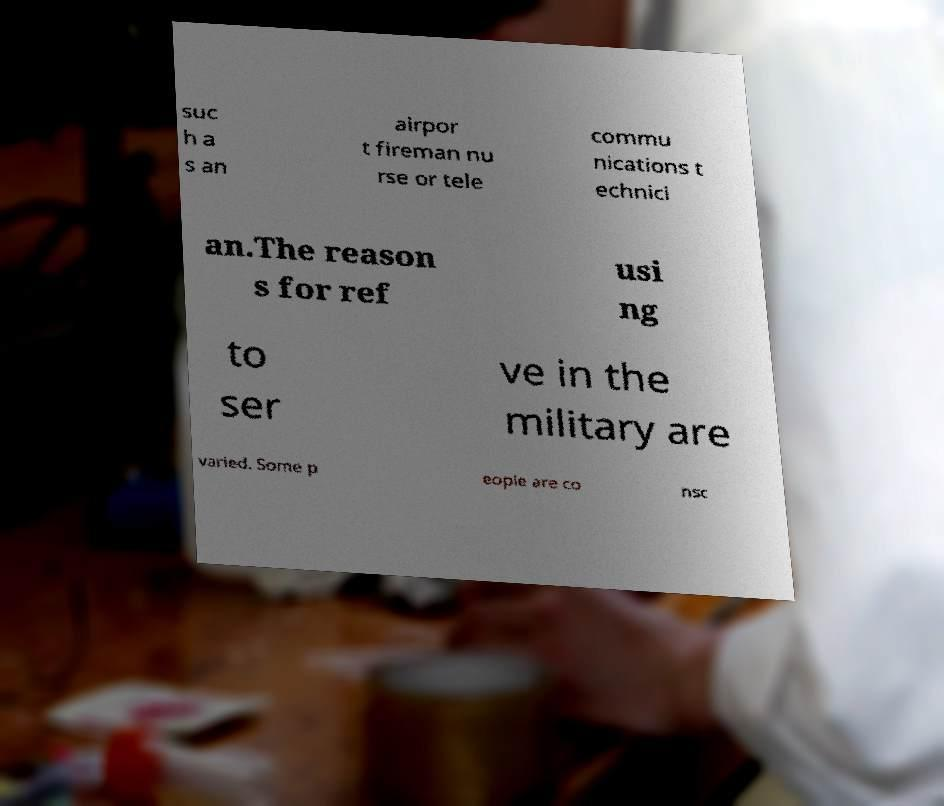I need the written content from this picture converted into text. Can you do that? suc h a s an airpor t fireman nu rse or tele commu nications t echnici an.The reason s for ref usi ng to ser ve in the military are varied. Some p eople are co nsc 